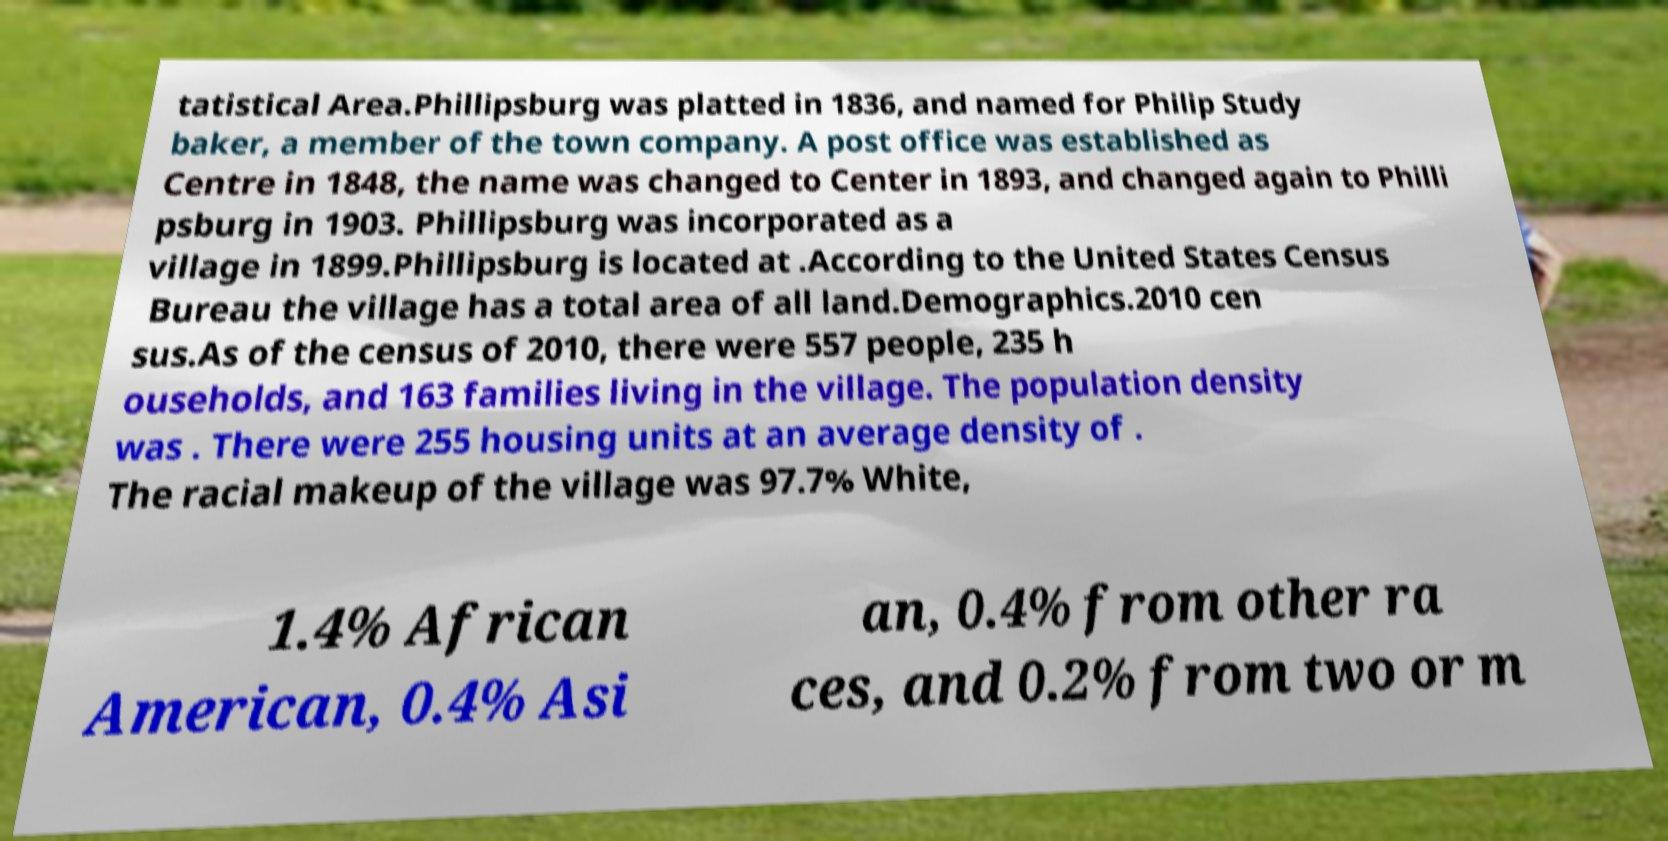Please read and relay the text visible in this image. What does it say? tatistical Area.Phillipsburg was platted in 1836, and named for Philip Study baker, a member of the town company. A post office was established as Centre in 1848, the name was changed to Center in 1893, and changed again to Philli psburg in 1903. Phillipsburg was incorporated as a village in 1899.Phillipsburg is located at .According to the United States Census Bureau the village has a total area of all land.Demographics.2010 cen sus.As of the census of 2010, there were 557 people, 235 h ouseholds, and 163 families living in the village. The population density was . There were 255 housing units at an average density of . The racial makeup of the village was 97.7% White, 1.4% African American, 0.4% Asi an, 0.4% from other ra ces, and 0.2% from two or m 